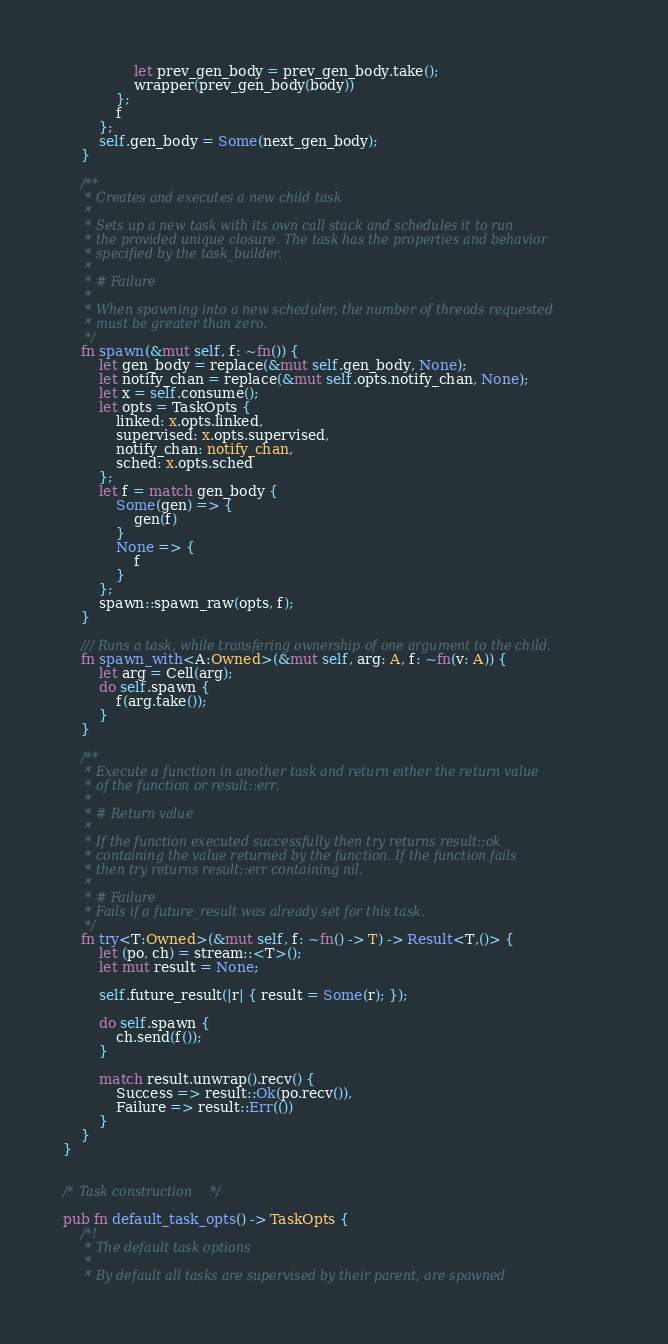<code> <loc_0><loc_0><loc_500><loc_500><_Rust_>                let prev_gen_body = prev_gen_body.take();
                wrapper(prev_gen_body(body))
            };
            f
        };
        self.gen_body = Some(next_gen_body);
    }

    /**
     * Creates and executes a new child task
     *
     * Sets up a new task with its own call stack and schedules it to run
     * the provided unique closure. The task has the properties and behavior
     * specified by the task_builder.
     *
     * # Failure
     *
     * When spawning into a new scheduler, the number of threads requested
     * must be greater than zero.
     */
    fn spawn(&mut self, f: ~fn()) {
        let gen_body = replace(&mut self.gen_body, None);
        let notify_chan = replace(&mut self.opts.notify_chan, None);
        let x = self.consume();
        let opts = TaskOpts {
            linked: x.opts.linked,
            supervised: x.opts.supervised,
            notify_chan: notify_chan,
            sched: x.opts.sched
        };
        let f = match gen_body {
            Some(gen) => {
                gen(f)
            }
            None => {
                f
            }
        };
        spawn::spawn_raw(opts, f);
    }

    /// Runs a task, while transfering ownership of one argument to the child.
    fn spawn_with<A:Owned>(&mut self, arg: A, f: ~fn(v: A)) {
        let arg = Cell(arg);
        do self.spawn {
            f(arg.take());
        }
    }

    /**
     * Execute a function in another task and return either the return value
     * of the function or result::err.
     *
     * # Return value
     *
     * If the function executed successfully then try returns result::ok
     * containing the value returned by the function. If the function fails
     * then try returns result::err containing nil.
     *
     * # Failure
     * Fails if a future_result was already set for this task.
     */
    fn try<T:Owned>(&mut self, f: ~fn() -> T) -> Result<T,()> {
        let (po, ch) = stream::<T>();
        let mut result = None;

        self.future_result(|r| { result = Some(r); });

        do self.spawn {
            ch.send(f());
        }

        match result.unwrap().recv() {
            Success => result::Ok(po.recv()),
            Failure => result::Err(())
        }
    }
}


/* Task construction */

pub fn default_task_opts() -> TaskOpts {
    /*!
     * The default task options
     *
     * By default all tasks are supervised by their parent, are spawned</code> 